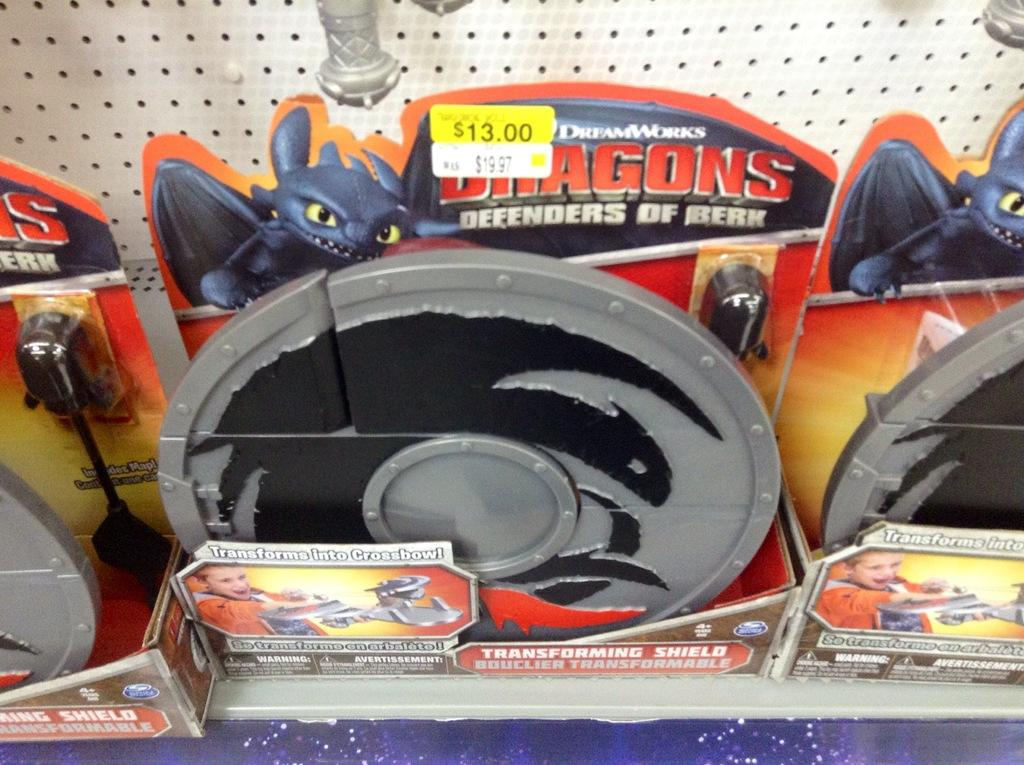What type of objects can be seen in the image? There are toys in the image. How many bushes are present in the image? There are no bushes mentioned or visible in the image; it only contains toys. What type of fruit can be seen hanging from the light in the image? There is no light or fruit present in the image; it only contains toys. 